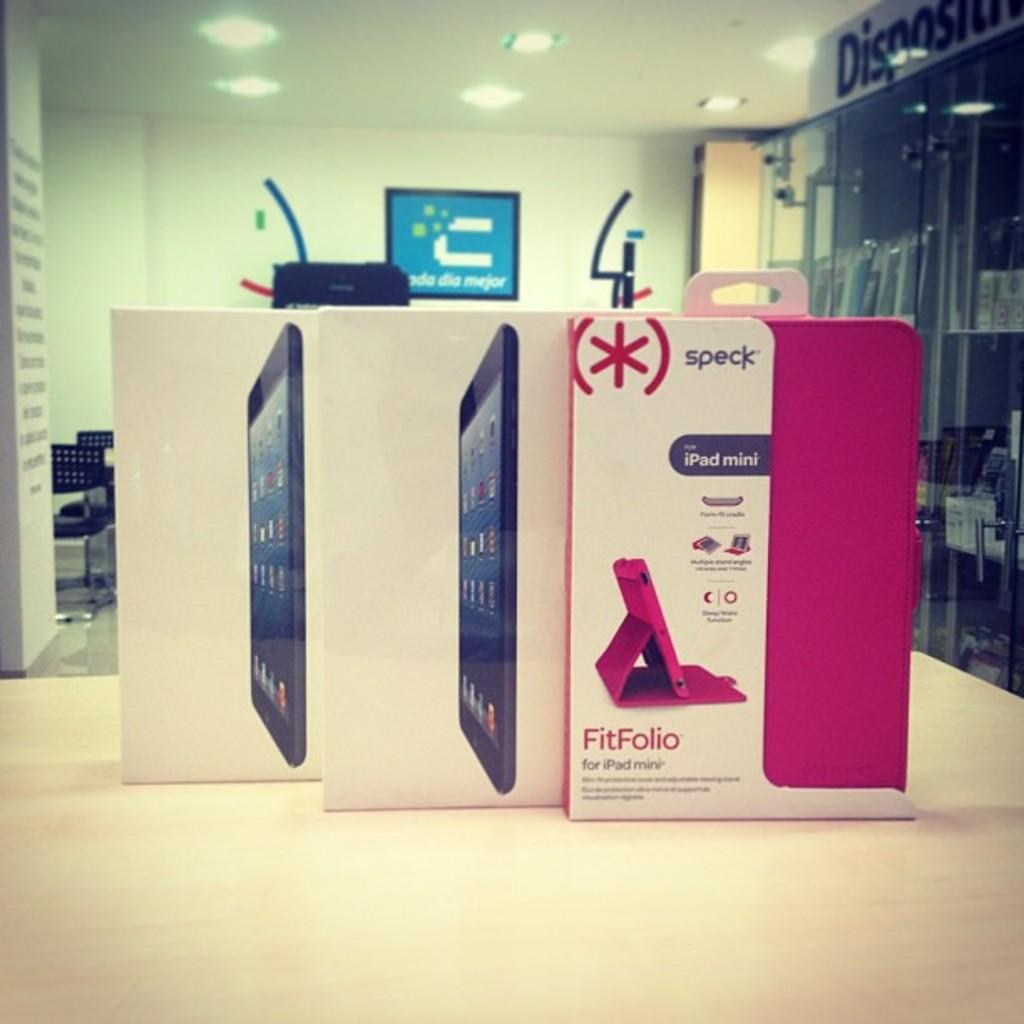<image>
Render a clear and concise summary of the photo. A bright pink tablet cover called a Speck FitFolio. 